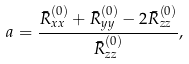<formula> <loc_0><loc_0><loc_500><loc_500>a = \frac { \bar { R } _ { x x } ^ { ( 0 ) } + \bar { R } _ { y y } ^ { ( 0 ) } - 2 \bar { R } _ { z z } ^ { ( 0 ) } } { \bar { R } _ { z z } ^ { ( 0 ) } } ,</formula> 